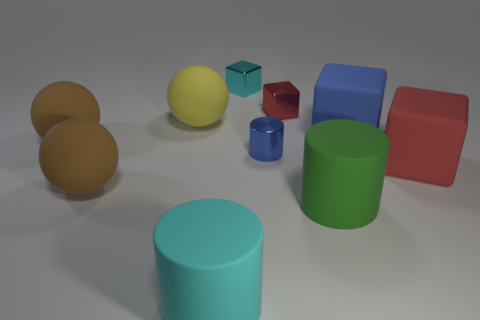Subtract 1 blocks. How many blocks are left? 3 Subtract all gray cubes. Subtract all blue cylinders. How many cubes are left? 4 Subtract all blocks. How many objects are left? 6 Subtract 0 red balls. How many objects are left? 10 Subtract all tiny yellow metal objects. Subtract all yellow objects. How many objects are left? 9 Add 1 large yellow matte spheres. How many large yellow matte spheres are left? 2 Add 2 tiny brown rubber cylinders. How many tiny brown rubber cylinders exist? 2 